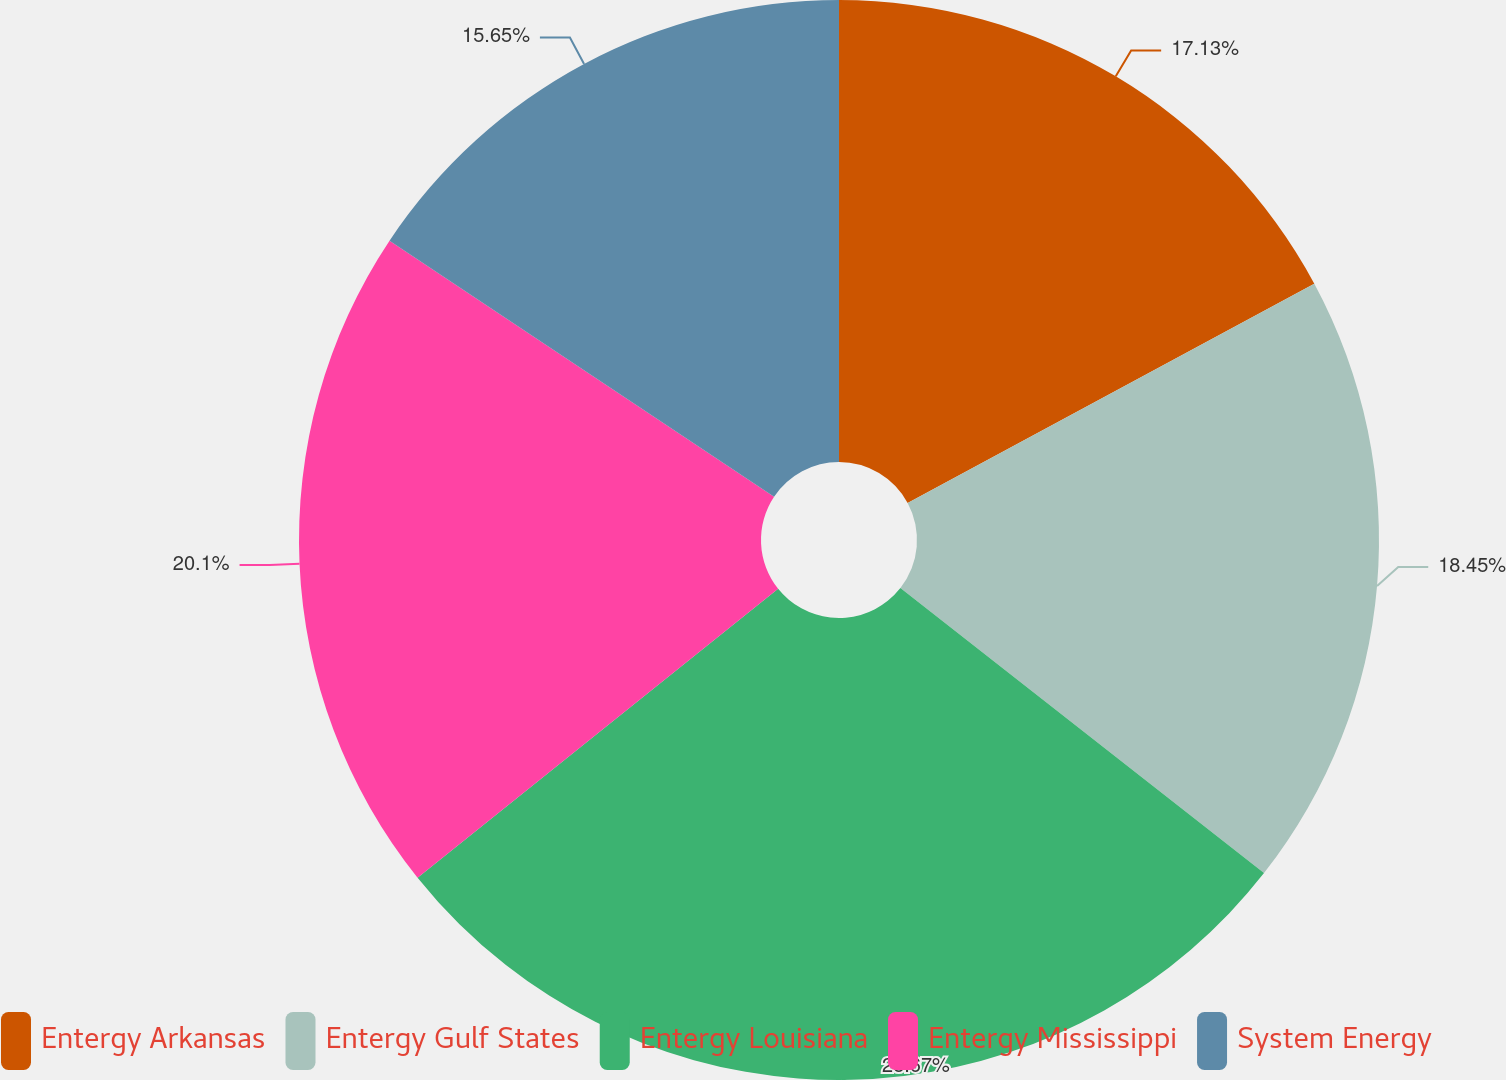<chart> <loc_0><loc_0><loc_500><loc_500><pie_chart><fcel>Entergy Arkansas<fcel>Entergy Gulf States<fcel>Entergy Louisiana<fcel>Entergy Mississippi<fcel>System Energy<nl><fcel>17.13%<fcel>18.45%<fcel>28.67%<fcel>20.1%<fcel>15.65%<nl></chart> 